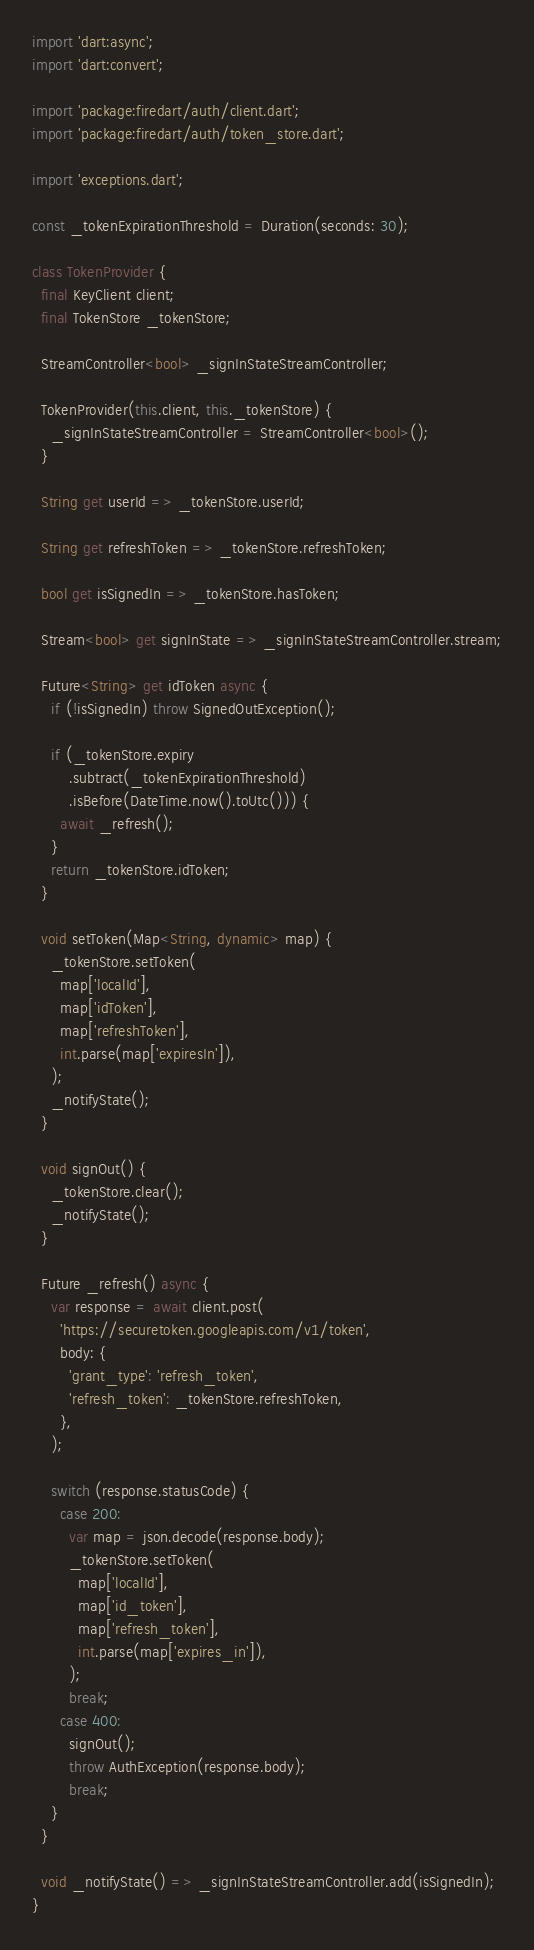Convert code to text. <code><loc_0><loc_0><loc_500><loc_500><_Dart_>import 'dart:async';
import 'dart:convert';

import 'package:firedart/auth/client.dart';
import 'package:firedart/auth/token_store.dart';

import 'exceptions.dart';

const _tokenExpirationThreshold = Duration(seconds: 30);

class TokenProvider {
  final KeyClient client;
  final TokenStore _tokenStore;

  StreamController<bool> _signInStateStreamController;

  TokenProvider(this.client, this._tokenStore) {
    _signInStateStreamController = StreamController<bool>();
  }

  String get userId => _tokenStore.userId;

  String get refreshToken => _tokenStore.refreshToken;

  bool get isSignedIn => _tokenStore.hasToken;

  Stream<bool> get signInState => _signInStateStreamController.stream;

  Future<String> get idToken async {
    if (!isSignedIn) throw SignedOutException();

    if (_tokenStore.expiry
        .subtract(_tokenExpirationThreshold)
        .isBefore(DateTime.now().toUtc())) {
      await _refresh();
    }
    return _tokenStore.idToken;
  }

  void setToken(Map<String, dynamic> map) {
    _tokenStore.setToken(
      map['localId'],
      map['idToken'],
      map['refreshToken'],
      int.parse(map['expiresIn']),
    );
    _notifyState();
  }

  void signOut() {
    _tokenStore.clear();
    _notifyState();
  }

  Future _refresh() async {
    var response = await client.post(
      'https://securetoken.googleapis.com/v1/token',
      body: {
        'grant_type': 'refresh_token',
        'refresh_token': _tokenStore.refreshToken,
      },
    );

    switch (response.statusCode) {
      case 200:
        var map = json.decode(response.body);
        _tokenStore.setToken(
          map['localId'],
          map['id_token'],
          map['refresh_token'],
          int.parse(map['expires_in']),
        );
        break;
      case 400:
        signOut();
        throw AuthException(response.body);
        break;
    }
  }

  void _notifyState() => _signInStateStreamController.add(isSignedIn);
}
</code> 